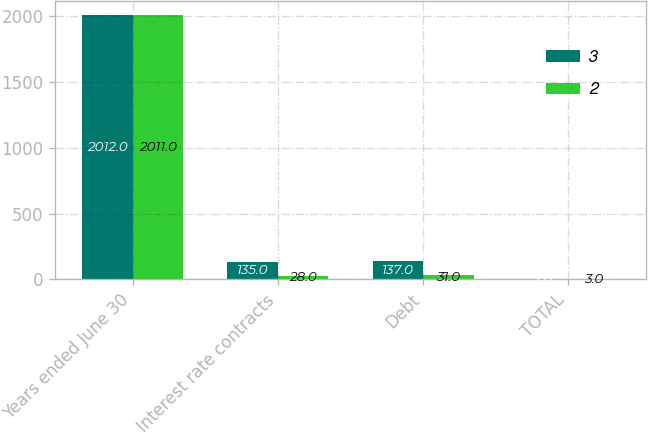Convert chart to OTSL. <chart><loc_0><loc_0><loc_500><loc_500><stacked_bar_chart><ecel><fcel>Years ended June 30<fcel>Interest rate contracts<fcel>Debt<fcel>TOTAL<nl><fcel>3<fcel>2012<fcel>135<fcel>137<fcel>2<nl><fcel>2<fcel>2011<fcel>28<fcel>31<fcel>3<nl></chart> 